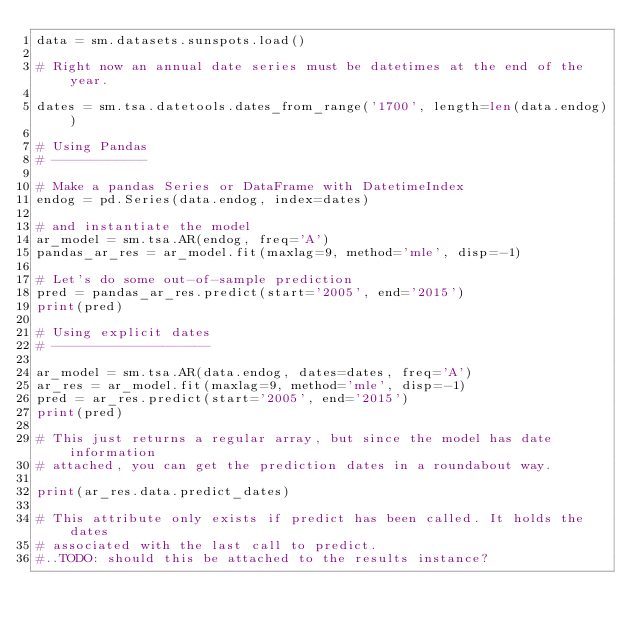Convert code to text. <code><loc_0><loc_0><loc_500><loc_500><_Python_>data = sm.datasets.sunspots.load()

# Right now an annual date series must be datetimes at the end of the year.

dates = sm.tsa.datetools.dates_from_range('1700', length=len(data.endog))

# Using Pandas
# ------------

# Make a pandas Series or DataFrame with DatetimeIndex
endog = pd.Series(data.endog, index=dates)

# and instantiate the model
ar_model = sm.tsa.AR(endog, freq='A')
pandas_ar_res = ar_model.fit(maxlag=9, method='mle', disp=-1)

# Let's do some out-of-sample prediction
pred = pandas_ar_res.predict(start='2005', end='2015')
print(pred)

# Using explicit dates
# --------------------

ar_model = sm.tsa.AR(data.endog, dates=dates, freq='A')
ar_res = ar_model.fit(maxlag=9, method='mle', disp=-1)
pred = ar_res.predict(start='2005', end='2015')
print(pred)

# This just returns a regular array, but since the model has date information
# attached, you can get the prediction dates in a roundabout way.

print(ar_res.data.predict_dates)

# This attribute only exists if predict has been called. It holds the dates
# associated with the last call to predict.
#..TODO: should this be attached to the results instance?
</code> 